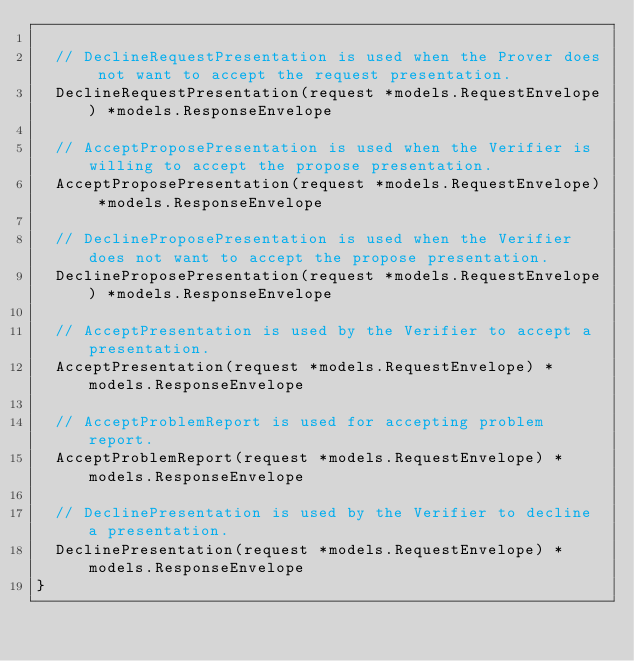Convert code to text. <code><loc_0><loc_0><loc_500><loc_500><_Go_>
	// DeclineRequestPresentation is used when the Prover does not want to accept the request presentation.
	DeclineRequestPresentation(request *models.RequestEnvelope) *models.ResponseEnvelope

	// AcceptProposePresentation is used when the Verifier is willing to accept the propose presentation.
	AcceptProposePresentation(request *models.RequestEnvelope) *models.ResponseEnvelope

	// DeclineProposePresentation is used when the Verifier does not want to accept the propose presentation.
	DeclineProposePresentation(request *models.RequestEnvelope) *models.ResponseEnvelope

	// AcceptPresentation is used by the Verifier to accept a presentation.
	AcceptPresentation(request *models.RequestEnvelope) *models.ResponseEnvelope

	// AcceptProblemReport is used for accepting problem report.
	AcceptProblemReport(request *models.RequestEnvelope) *models.ResponseEnvelope

	// DeclinePresentation is used by the Verifier to decline a presentation.
	DeclinePresentation(request *models.RequestEnvelope) *models.ResponseEnvelope
}
</code> 